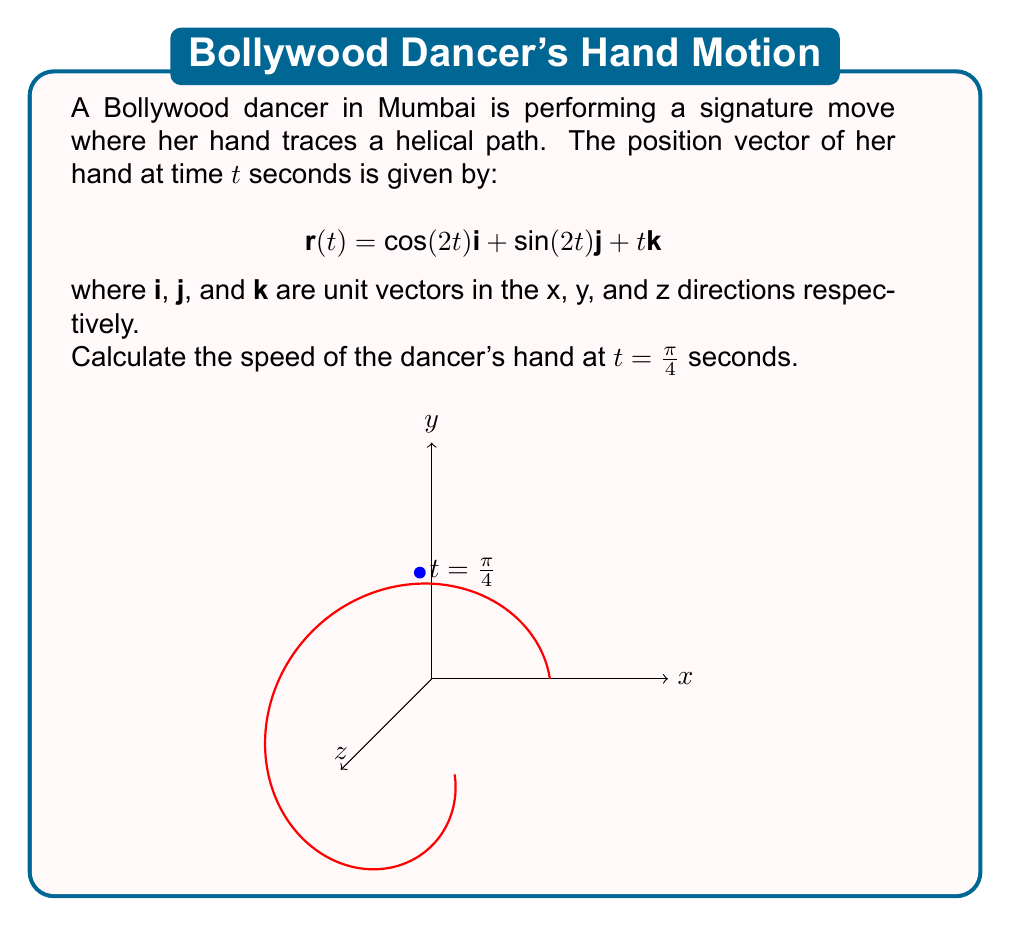Give your solution to this math problem. To find the speed of the dancer's hand, we need to calculate the magnitude of the velocity vector at $t = \frac{\pi}{4}$. Let's approach this step-by-step:

1) First, we need to find the velocity vector $\mathbf{v}(t)$ by differentiating $\mathbf{r}(t)$ with respect to $t$:

   $$\mathbf{v}(t) = \frac{d\mathbf{r}}{dt} = -2\sin(2t)\mathbf{i} + 2\cos(2t)\mathbf{j} + \mathbf{k}$$

2) Now, we need to evaluate this at $t = \frac{\pi}{4}$:

   $$\mathbf{v}(\frac{\pi}{4}) = -2\sin(\frac{\pi}{2})\mathbf{i} + 2\cos(\frac{\pi}{2})\mathbf{j} + \mathbf{k}$$

3) Simplify:
   
   $$\mathbf{v}(\frac{\pi}{4}) = -2\mathbf{i} + 0\mathbf{j} + \mathbf{k}$$

4) The speed is the magnitude of the velocity vector. We can calculate this using the Pythagorean theorem:

   $$\text{speed} = \|\mathbf{v}(\frac{\pi}{4})\| = \sqrt{(-2)^2 + 0^2 + 1^2} = \sqrt{4 + 0 + 1} = \sqrt{5}$$

Therefore, the speed of the dancer's hand at $t = \frac{\pi}{4}$ seconds is $\sqrt{5}$ units per second.
Answer: $\sqrt{5}$ units/second 